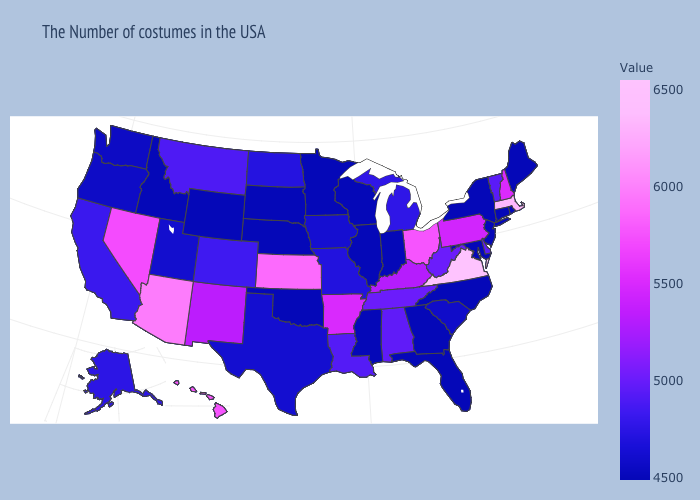Among the states that border Montana , which have the highest value?
Concise answer only. North Dakota. Which states have the lowest value in the MidWest?
Quick response, please. Indiana, Wisconsin, Illinois, Minnesota, Nebraska, South Dakota. Does Michigan have a lower value than West Virginia?
Short answer required. Yes. Does Hawaii have the highest value in the USA?
Be succinct. No. Is the legend a continuous bar?
Answer briefly. Yes. Does New Hampshire have the lowest value in the Northeast?
Be succinct. No. Does Mississippi have the lowest value in the USA?
Answer briefly. Yes. 